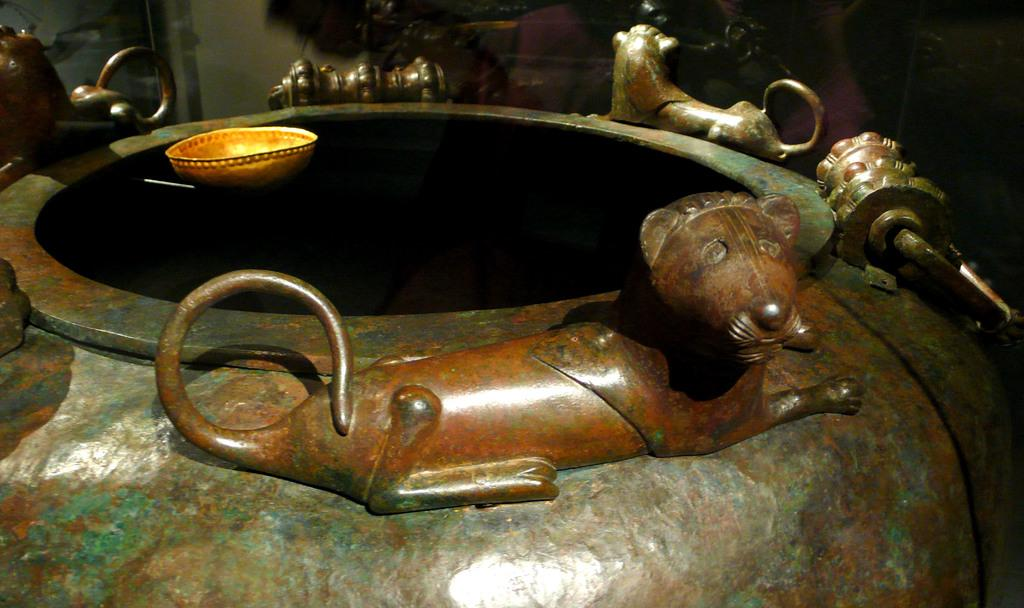What is the main object in the image? There is a vessel in the image. What decorative feature is present on the vessel? The vessel has a lion structure on it. What other object can be seen in the image? There is a bowl in the image. Where is the flower located in the image? There is no flower present in the image. Can you tell me which country the map in the image represents? There is no map present in the image. 